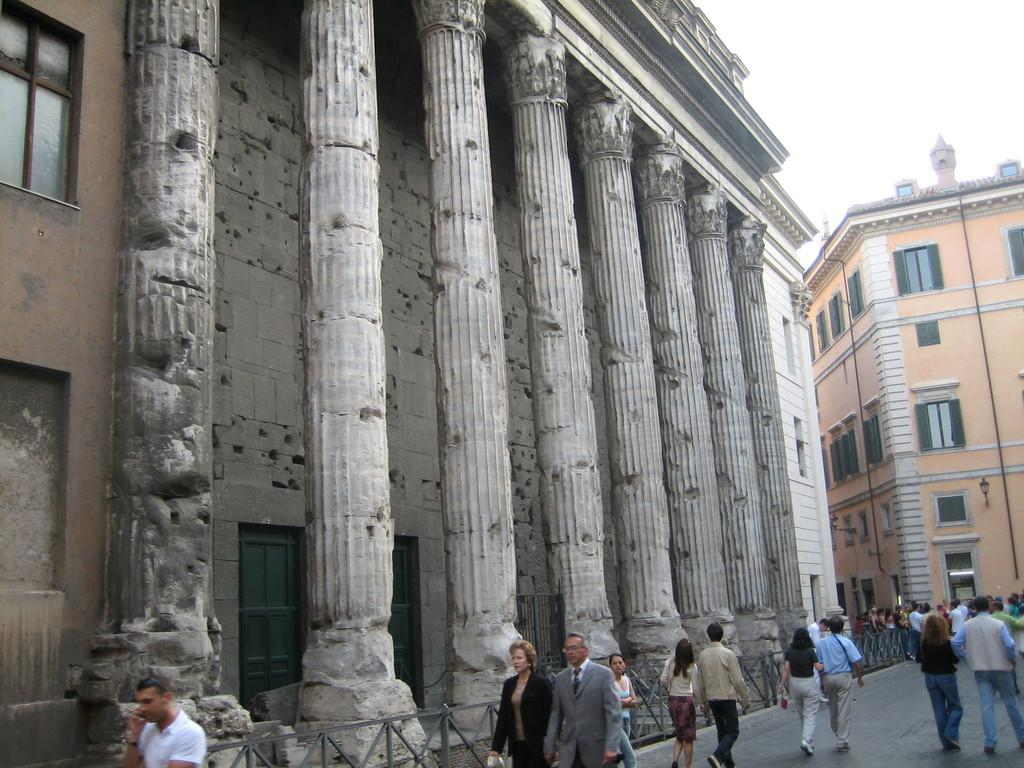Where was the image taken? The image was clicked outside. What can be seen in the middle of the image? There are buildings in the middle of the image. What activity are the people engaged in at the bottom of the image? The people are walking at the bottom of the image. What is visible at the top of the image? The sky is visible at the top of the image. What type of sand can be seen in the image? There is no sand present in the image. Is there a quill used for writing in the image? There is no quill visible in the image. 